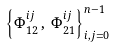<formula> <loc_0><loc_0><loc_500><loc_500>\left \{ \Phi ^ { i j } _ { 1 2 } \, , \, \Phi ^ { i j } _ { 2 1 } \right \} ^ { n - 1 } _ { i , j = 0 }</formula> 